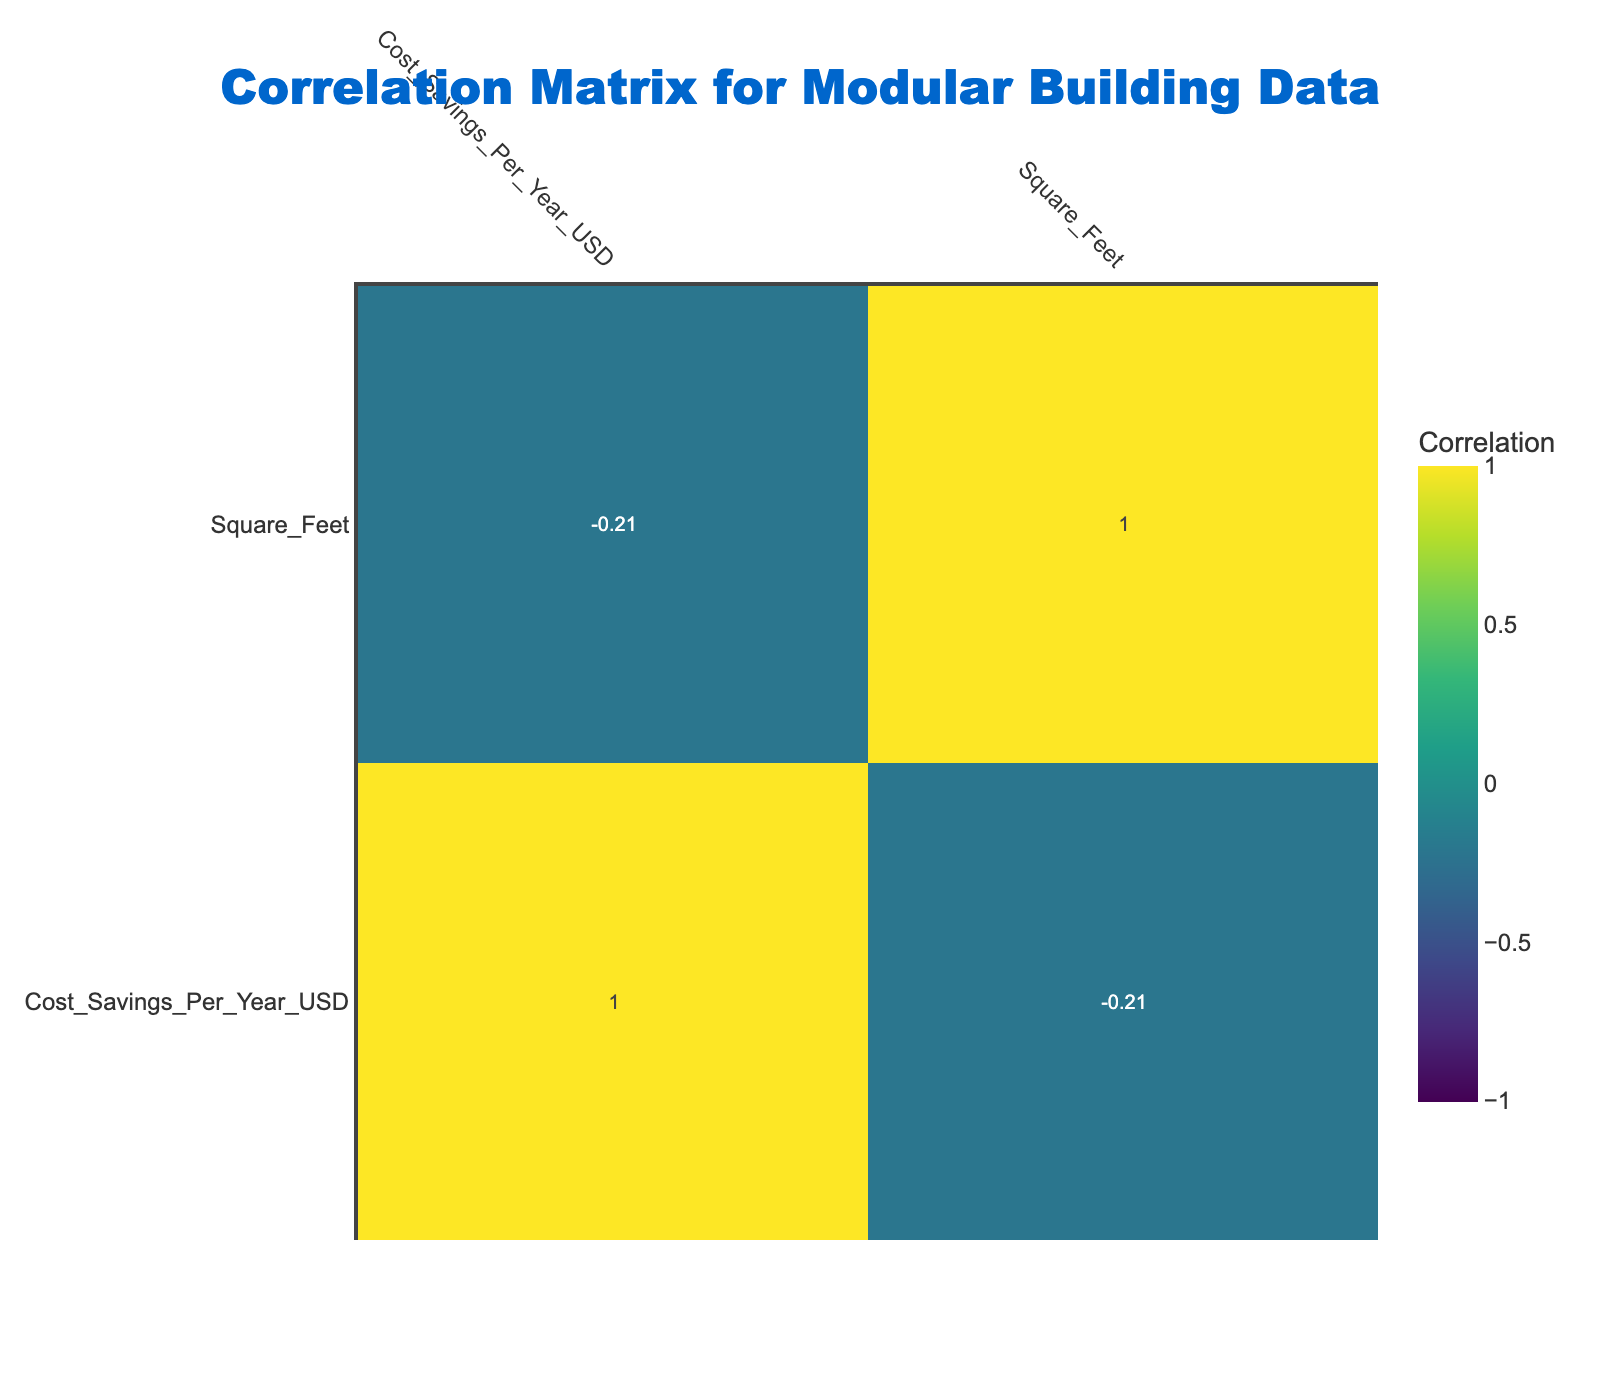What is the highest cost-saving energy efficiency rating among the building types? The highest cost savings is reported for the energy efficiency rating of A+, which is $1500. This is the maximum value found in the "Cost Savings Per Year USD" column.
Answer: A+ How much cost savings can be expected for a Modular Home with a B+ rating? The "Cost Savings Per Year USD" for a Modular Home with a B+ rating is $800, as specified in the respective row of the table.
Answer: 800 What is the average cost savings for building types with an energy efficiency rating above B? There are three building types with an energy efficiency rating above B: A+ ($1500), A ($1200), and B+ ($800). The sum of these savings is 1500 + 1200 + 800 = 3500. Dividing by the number of building types (3), we get 3500/3 = 1166.67. Therefore, the average is approximately $1167.
Answer: 1167 Is there a modular building type with a cost saving of more than $1000? Yes, there are two modular buildings with cost savings above $1000: the Modular Office (A+ rating) with $1500 and the Modular School (A rating) with $1200.
Answer: Yes Which energy efficiency rating corresponds to the lowest cost savings? The lowest cost savings corresponds to the energy efficiency rating of D, which shows $50 in the 'Cost Savings Per Year USD' column. This is the minimum value in that column.
Answer: D 